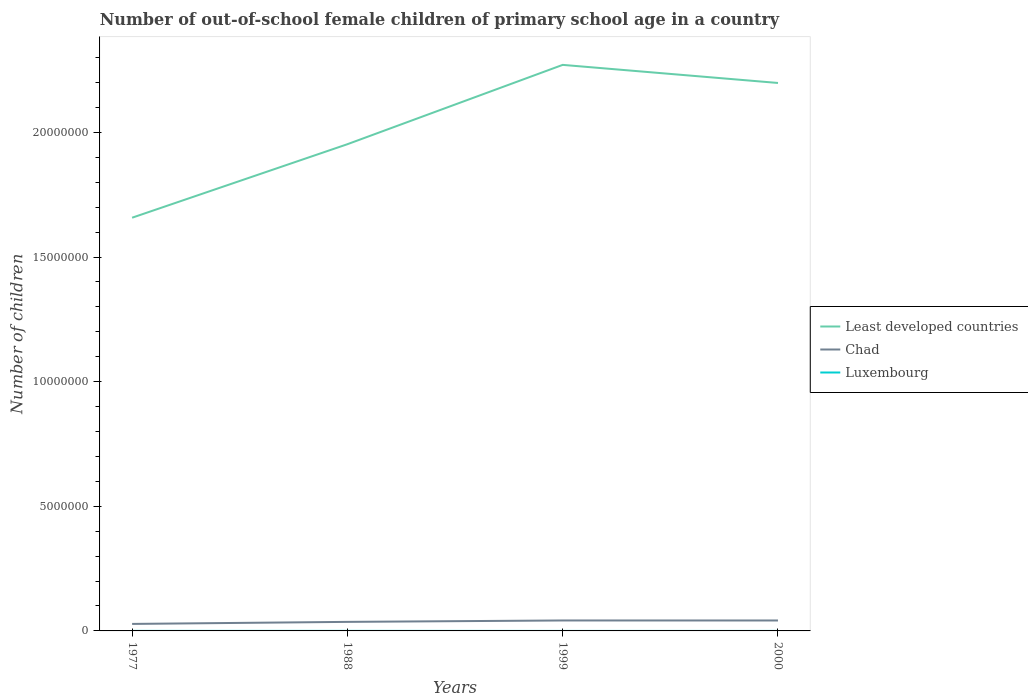How many different coloured lines are there?
Make the answer very short. 3. Is the number of lines equal to the number of legend labels?
Keep it short and to the point. Yes. Across all years, what is the maximum number of out-of-school female children in Least developed countries?
Your answer should be very brief. 1.66e+07. What is the total number of out-of-school female children in Least developed countries in the graph?
Keep it short and to the point. -3.18e+06. What is the difference between the highest and the second highest number of out-of-school female children in Luxembourg?
Give a very brief answer. 1433. What is the difference between the highest and the lowest number of out-of-school female children in Chad?
Your answer should be compact. 2. Is the number of out-of-school female children in Luxembourg strictly greater than the number of out-of-school female children in Least developed countries over the years?
Your answer should be compact. Yes. How many lines are there?
Your response must be concise. 3. How many years are there in the graph?
Your answer should be very brief. 4. What is the difference between two consecutive major ticks on the Y-axis?
Your answer should be very brief. 5.00e+06. Are the values on the major ticks of Y-axis written in scientific E-notation?
Keep it short and to the point. No. Where does the legend appear in the graph?
Provide a short and direct response. Center right. How many legend labels are there?
Keep it short and to the point. 3. How are the legend labels stacked?
Provide a short and direct response. Vertical. What is the title of the graph?
Provide a succinct answer. Number of out-of-school female children of primary school age in a country. Does "Tajikistan" appear as one of the legend labels in the graph?
Your response must be concise. No. What is the label or title of the Y-axis?
Keep it short and to the point. Number of children. What is the Number of children of Least developed countries in 1977?
Offer a very short reply. 1.66e+07. What is the Number of children in Chad in 1977?
Your response must be concise. 2.81e+05. What is the Number of children in Luxembourg in 1977?
Give a very brief answer. 1276. What is the Number of children of Least developed countries in 1988?
Provide a succinct answer. 1.95e+07. What is the Number of children in Chad in 1988?
Your answer should be compact. 3.63e+05. What is the Number of children in Luxembourg in 1988?
Make the answer very short. 1682. What is the Number of children in Least developed countries in 1999?
Offer a terse response. 2.27e+07. What is the Number of children in Chad in 1999?
Ensure brevity in your answer.  4.20e+05. What is the Number of children in Luxembourg in 1999?
Offer a very short reply. 249. What is the Number of children in Least developed countries in 2000?
Provide a succinct answer. 2.20e+07. What is the Number of children in Chad in 2000?
Keep it short and to the point. 4.19e+05. What is the Number of children in Luxembourg in 2000?
Offer a very short reply. 281. Across all years, what is the maximum Number of children in Least developed countries?
Your response must be concise. 2.27e+07. Across all years, what is the maximum Number of children of Chad?
Give a very brief answer. 4.20e+05. Across all years, what is the maximum Number of children of Luxembourg?
Keep it short and to the point. 1682. Across all years, what is the minimum Number of children in Least developed countries?
Provide a short and direct response. 1.66e+07. Across all years, what is the minimum Number of children in Chad?
Your answer should be compact. 2.81e+05. Across all years, what is the minimum Number of children in Luxembourg?
Your answer should be very brief. 249. What is the total Number of children in Least developed countries in the graph?
Keep it short and to the point. 8.08e+07. What is the total Number of children in Chad in the graph?
Your answer should be compact. 1.48e+06. What is the total Number of children in Luxembourg in the graph?
Give a very brief answer. 3488. What is the difference between the Number of children of Least developed countries in 1977 and that in 1988?
Keep it short and to the point. -2.95e+06. What is the difference between the Number of children in Chad in 1977 and that in 1988?
Your answer should be very brief. -8.20e+04. What is the difference between the Number of children in Luxembourg in 1977 and that in 1988?
Your response must be concise. -406. What is the difference between the Number of children of Least developed countries in 1977 and that in 1999?
Give a very brief answer. -6.13e+06. What is the difference between the Number of children of Chad in 1977 and that in 1999?
Provide a succinct answer. -1.39e+05. What is the difference between the Number of children of Luxembourg in 1977 and that in 1999?
Ensure brevity in your answer.  1027. What is the difference between the Number of children of Least developed countries in 1977 and that in 2000?
Provide a short and direct response. -5.41e+06. What is the difference between the Number of children in Chad in 1977 and that in 2000?
Ensure brevity in your answer.  -1.38e+05. What is the difference between the Number of children of Luxembourg in 1977 and that in 2000?
Provide a succinct answer. 995. What is the difference between the Number of children of Least developed countries in 1988 and that in 1999?
Make the answer very short. -3.18e+06. What is the difference between the Number of children of Chad in 1988 and that in 1999?
Your answer should be compact. -5.65e+04. What is the difference between the Number of children in Luxembourg in 1988 and that in 1999?
Provide a succinct answer. 1433. What is the difference between the Number of children in Least developed countries in 1988 and that in 2000?
Provide a succinct answer. -2.46e+06. What is the difference between the Number of children of Chad in 1988 and that in 2000?
Your answer should be compact. -5.57e+04. What is the difference between the Number of children of Luxembourg in 1988 and that in 2000?
Keep it short and to the point. 1401. What is the difference between the Number of children in Least developed countries in 1999 and that in 2000?
Offer a very short reply. 7.26e+05. What is the difference between the Number of children of Chad in 1999 and that in 2000?
Make the answer very short. 757. What is the difference between the Number of children in Luxembourg in 1999 and that in 2000?
Provide a short and direct response. -32. What is the difference between the Number of children of Least developed countries in 1977 and the Number of children of Chad in 1988?
Your response must be concise. 1.62e+07. What is the difference between the Number of children of Least developed countries in 1977 and the Number of children of Luxembourg in 1988?
Offer a terse response. 1.66e+07. What is the difference between the Number of children of Chad in 1977 and the Number of children of Luxembourg in 1988?
Make the answer very short. 2.79e+05. What is the difference between the Number of children of Least developed countries in 1977 and the Number of children of Chad in 1999?
Provide a short and direct response. 1.62e+07. What is the difference between the Number of children of Least developed countries in 1977 and the Number of children of Luxembourg in 1999?
Give a very brief answer. 1.66e+07. What is the difference between the Number of children of Chad in 1977 and the Number of children of Luxembourg in 1999?
Keep it short and to the point. 2.81e+05. What is the difference between the Number of children in Least developed countries in 1977 and the Number of children in Chad in 2000?
Provide a short and direct response. 1.62e+07. What is the difference between the Number of children of Least developed countries in 1977 and the Number of children of Luxembourg in 2000?
Give a very brief answer. 1.66e+07. What is the difference between the Number of children of Chad in 1977 and the Number of children of Luxembourg in 2000?
Your response must be concise. 2.81e+05. What is the difference between the Number of children of Least developed countries in 1988 and the Number of children of Chad in 1999?
Your answer should be very brief. 1.91e+07. What is the difference between the Number of children of Least developed countries in 1988 and the Number of children of Luxembourg in 1999?
Offer a very short reply. 1.95e+07. What is the difference between the Number of children in Chad in 1988 and the Number of children in Luxembourg in 1999?
Ensure brevity in your answer.  3.63e+05. What is the difference between the Number of children of Least developed countries in 1988 and the Number of children of Chad in 2000?
Your answer should be compact. 1.91e+07. What is the difference between the Number of children in Least developed countries in 1988 and the Number of children in Luxembourg in 2000?
Ensure brevity in your answer.  1.95e+07. What is the difference between the Number of children of Chad in 1988 and the Number of children of Luxembourg in 2000?
Provide a succinct answer. 3.63e+05. What is the difference between the Number of children in Least developed countries in 1999 and the Number of children in Chad in 2000?
Provide a succinct answer. 2.23e+07. What is the difference between the Number of children in Least developed countries in 1999 and the Number of children in Luxembourg in 2000?
Your answer should be compact. 2.27e+07. What is the difference between the Number of children of Chad in 1999 and the Number of children of Luxembourg in 2000?
Offer a very short reply. 4.19e+05. What is the average Number of children in Least developed countries per year?
Provide a succinct answer. 2.02e+07. What is the average Number of children in Chad per year?
Keep it short and to the point. 3.71e+05. What is the average Number of children in Luxembourg per year?
Your response must be concise. 872. In the year 1977, what is the difference between the Number of children of Least developed countries and Number of children of Chad?
Make the answer very short. 1.63e+07. In the year 1977, what is the difference between the Number of children of Least developed countries and Number of children of Luxembourg?
Give a very brief answer. 1.66e+07. In the year 1977, what is the difference between the Number of children in Chad and Number of children in Luxembourg?
Ensure brevity in your answer.  2.80e+05. In the year 1988, what is the difference between the Number of children in Least developed countries and Number of children in Chad?
Offer a very short reply. 1.92e+07. In the year 1988, what is the difference between the Number of children of Least developed countries and Number of children of Luxembourg?
Your answer should be very brief. 1.95e+07. In the year 1988, what is the difference between the Number of children of Chad and Number of children of Luxembourg?
Your response must be concise. 3.61e+05. In the year 1999, what is the difference between the Number of children of Least developed countries and Number of children of Chad?
Provide a succinct answer. 2.23e+07. In the year 1999, what is the difference between the Number of children of Least developed countries and Number of children of Luxembourg?
Your answer should be very brief. 2.27e+07. In the year 1999, what is the difference between the Number of children of Chad and Number of children of Luxembourg?
Your response must be concise. 4.19e+05. In the year 2000, what is the difference between the Number of children of Least developed countries and Number of children of Chad?
Offer a very short reply. 2.16e+07. In the year 2000, what is the difference between the Number of children of Least developed countries and Number of children of Luxembourg?
Provide a short and direct response. 2.20e+07. In the year 2000, what is the difference between the Number of children in Chad and Number of children in Luxembourg?
Give a very brief answer. 4.19e+05. What is the ratio of the Number of children in Least developed countries in 1977 to that in 1988?
Offer a very short reply. 0.85. What is the ratio of the Number of children in Chad in 1977 to that in 1988?
Your answer should be very brief. 0.77. What is the ratio of the Number of children of Luxembourg in 1977 to that in 1988?
Offer a very short reply. 0.76. What is the ratio of the Number of children in Least developed countries in 1977 to that in 1999?
Your response must be concise. 0.73. What is the ratio of the Number of children of Chad in 1977 to that in 1999?
Make the answer very short. 0.67. What is the ratio of the Number of children in Luxembourg in 1977 to that in 1999?
Offer a terse response. 5.12. What is the ratio of the Number of children of Least developed countries in 1977 to that in 2000?
Give a very brief answer. 0.75. What is the ratio of the Number of children in Chad in 1977 to that in 2000?
Make the answer very short. 0.67. What is the ratio of the Number of children of Luxembourg in 1977 to that in 2000?
Keep it short and to the point. 4.54. What is the ratio of the Number of children in Least developed countries in 1988 to that in 1999?
Your response must be concise. 0.86. What is the ratio of the Number of children in Chad in 1988 to that in 1999?
Provide a succinct answer. 0.87. What is the ratio of the Number of children of Luxembourg in 1988 to that in 1999?
Keep it short and to the point. 6.75. What is the ratio of the Number of children in Least developed countries in 1988 to that in 2000?
Your response must be concise. 0.89. What is the ratio of the Number of children in Chad in 1988 to that in 2000?
Provide a short and direct response. 0.87. What is the ratio of the Number of children of Luxembourg in 1988 to that in 2000?
Your answer should be compact. 5.99. What is the ratio of the Number of children in Least developed countries in 1999 to that in 2000?
Keep it short and to the point. 1.03. What is the ratio of the Number of children in Luxembourg in 1999 to that in 2000?
Offer a terse response. 0.89. What is the difference between the highest and the second highest Number of children of Least developed countries?
Provide a succinct answer. 7.26e+05. What is the difference between the highest and the second highest Number of children of Chad?
Provide a succinct answer. 757. What is the difference between the highest and the second highest Number of children in Luxembourg?
Offer a terse response. 406. What is the difference between the highest and the lowest Number of children in Least developed countries?
Ensure brevity in your answer.  6.13e+06. What is the difference between the highest and the lowest Number of children in Chad?
Provide a short and direct response. 1.39e+05. What is the difference between the highest and the lowest Number of children of Luxembourg?
Keep it short and to the point. 1433. 